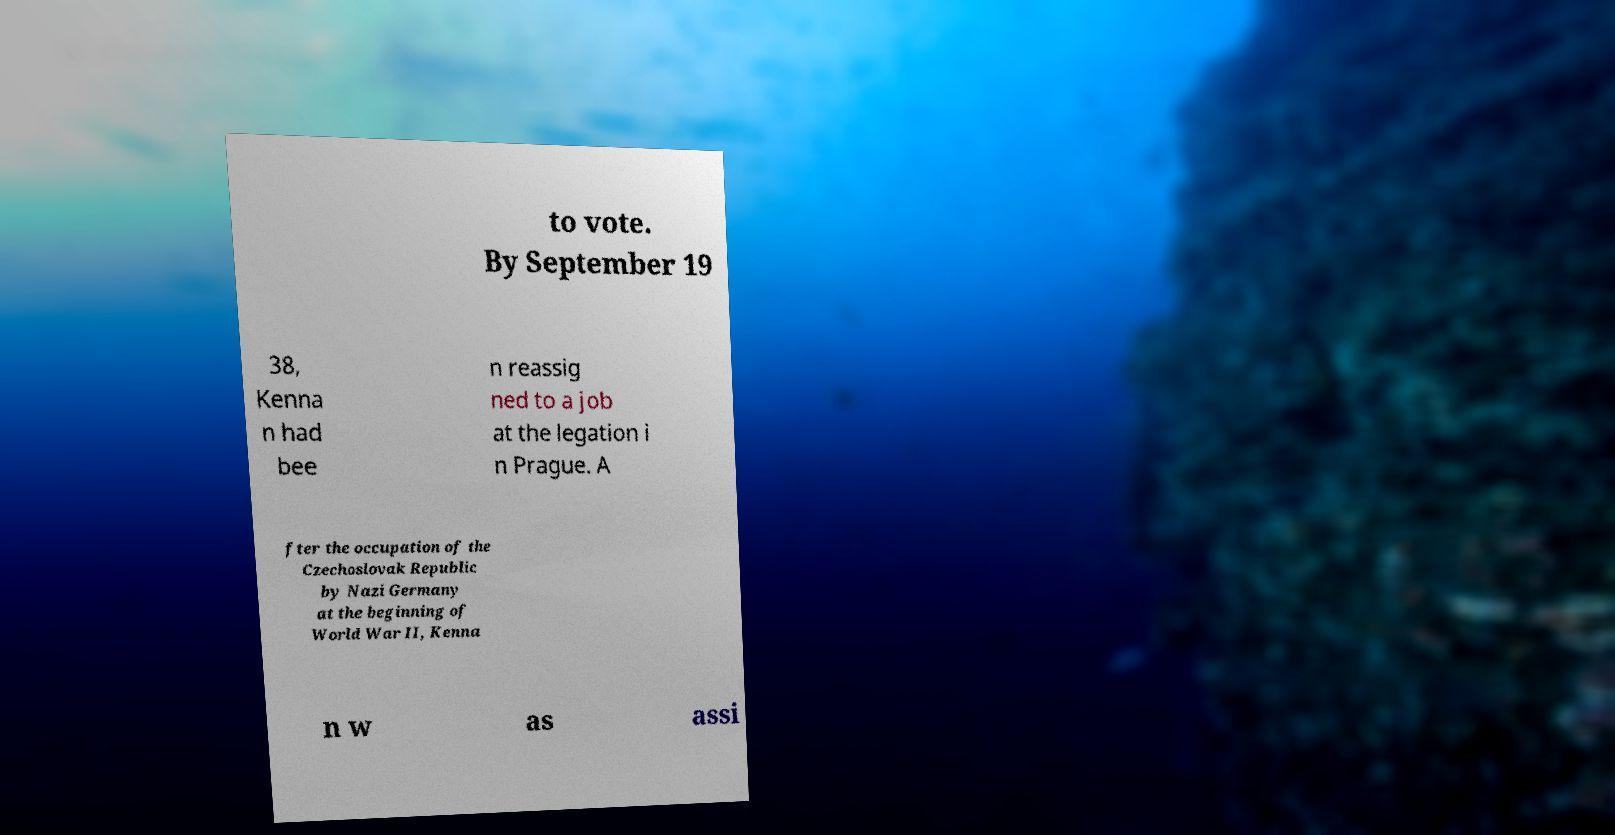What messages or text are displayed in this image? I need them in a readable, typed format. to vote. By September 19 38, Kenna n had bee n reassig ned to a job at the legation i n Prague. A fter the occupation of the Czechoslovak Republic by Nazi Germany at the beginning of World War II, Kenna n w as assi 